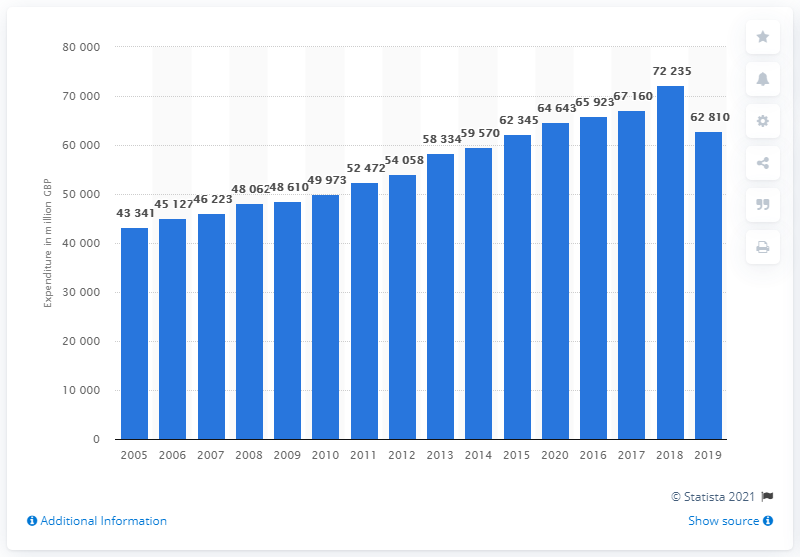Draw attention to some important aspects in this diagram. According to estimates, the apparel and footwear market in the UK is valued at approximately 659,230. 